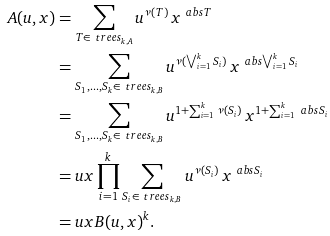<formula> <loc_0><loc_0><loc_500><loc_500>A ( u , x ) & = \sum _ { T \in \ t r e e s _ { k , A } } u ^ { \nu ( T ) } \, x ^ { \ a b s { T } } \\ & = \sum _ { S _ { 1 } , \dots , S _ { k } \in \ t r e e s _ { k , B } } u ^ { \nu ( \bigvee _ { i = 1 } ^ { k } S _ { i } ) } \, x ^ { \ a b s { \bigvee _ { i = 1 } ^ { k } S _ { i } } } \\ & = \sum _ { S _ { 1 } , \dots , S _ { k } \in \ t r e e s _ { k , B } } u ^ { 1 + \sum _ { i = 1 } ^ { k } \nu ( S _ { i } ) } \, x ^ { 1 + \sum _ { i = 1 } ^ { k } \ a b s { S _ { i } } } \\ & = u x \prod _ { i = 1 } ^ { k } \sum _ { S _ { i } \in \ t r e e s _ { k , B } } u ^ { \nu ( S _ { i } ) } \, x ^ { \ a b s { S _ { i } } } \\ & = u x B ( u , x ) ^ { k } .</formula> 